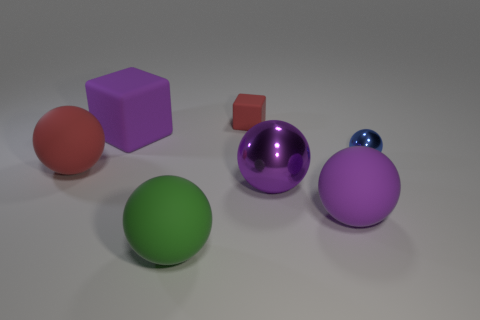Which of these objects stands out the most to you and why? The large purple ball stands out prominently due to its size, vibrant color, and the glossy reflective surface that catches the light, drawing the observer's attention.  If these objects were part of a piece of artwork, what theme do you think the artist might be exploring? If these objects were components of an art installation, the artist might be exploring themes of simplicity and complexity—showcasing basic geometric shapes in a clean and minimalist presentation. Another possible theme could be the interplay of color and light, as seen in the varying reflections and shades each object presents. 